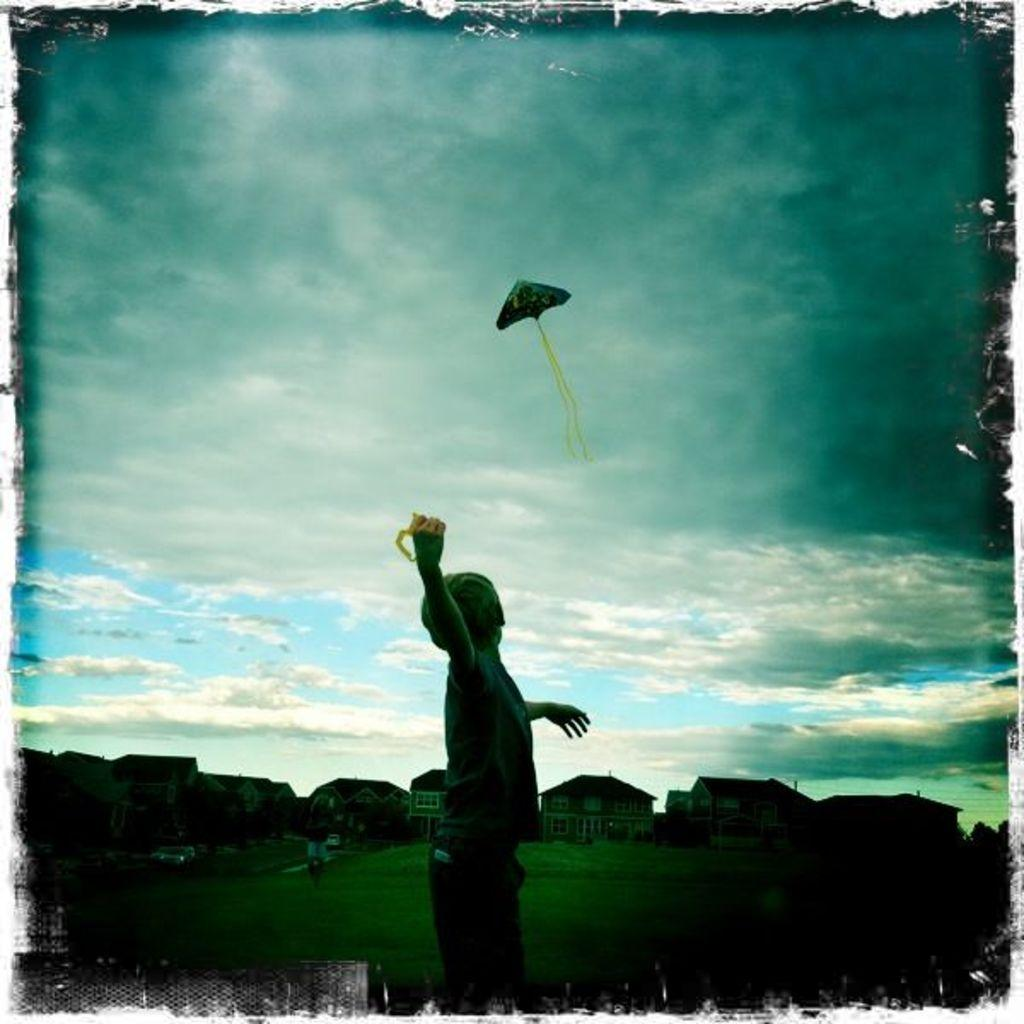What is the main subject of the image? There is a boy standing in the image. What can be seen in the background of the image? There are buildings with windows and a kite flying in the sky. What type of vegetation is visible in the image? There is grass visible in the image. What is the condition of the sky in the image? Clouds are visible in the sky. Can you tell me how many snails are crawling on the boy's shoes in the image? There are no snails visible on the boy's shoes in the image. What type of hope is the boy holding in the image? There is no object or symbol representing hope in the image; the boy is simply standing. 